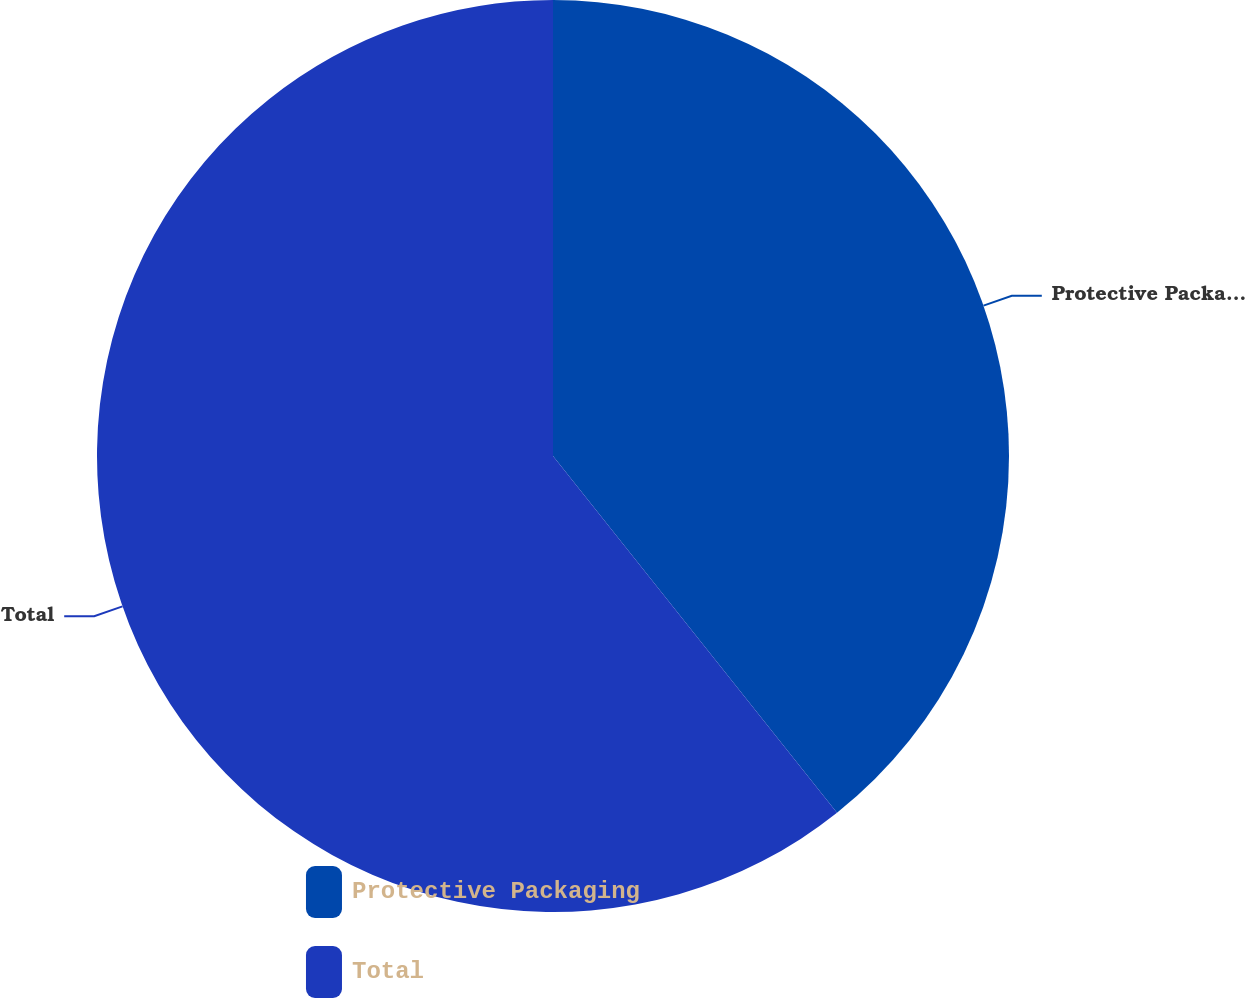<chart> <loc_0><loc_0><loc_500><loc_500><pie_chart><fcel>Protective Packaging<fcel>Total<nl><fcel>39.3%<fcel>60.7%<nl></chart> 